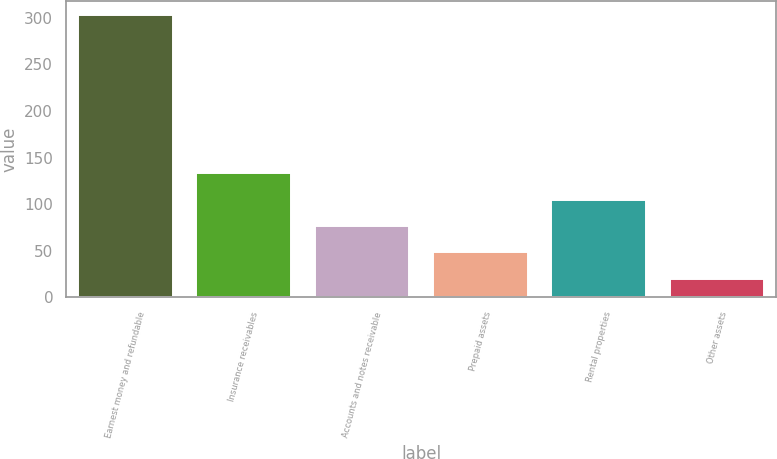<chart> <loc_0><loc_0><loc_500><loc_500><bar_chart><fcel>Earnest money and refundable<fcel>Insurance receivables<fcel>Accounts and notes receivable<fcel>Prepaid assets<fcel>Rental properties<fcel>Other assets<nl><fcel>303.1<fcel>133.3<fcel>76.7<fcel>48.4<fcel>105<fcel>20.1<nl></chart> 